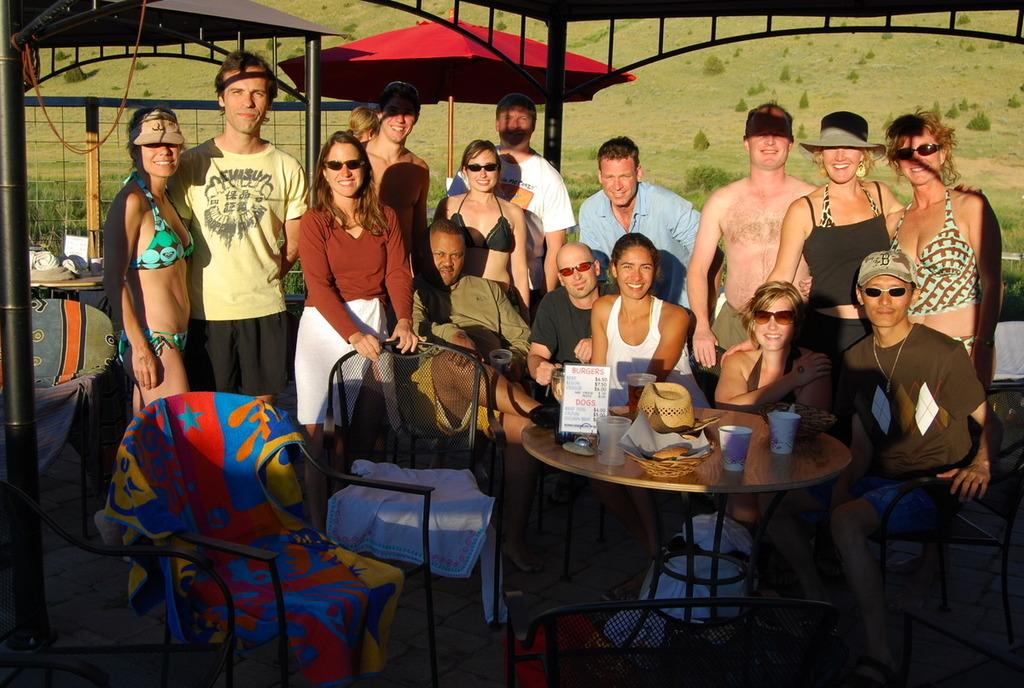How many people are in the image? There is a group of people in the image, but the exact number is not specified. What are some of the people doing in the image? Some of the people are sitting on chairs, while others are standing. What can be seen in the background of the image? There are tents and trees in the background of the image. What is visible on the ground in the image? The ground is visible in the image. What type of cap is being screwed onto the observation tower in the image? There is no cap or observation tower present in the image. 